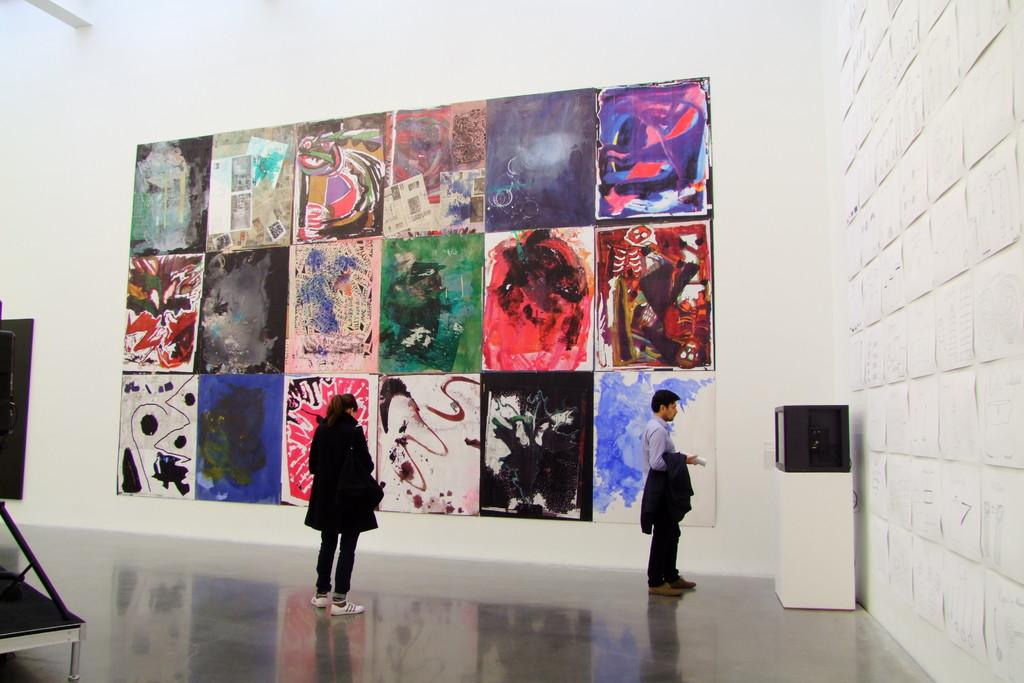How many people are present in the image? There are two people, a man and a woman, present in the image. What are the man and woman doing in the image? Both the man and woman are standing on the floor. What can be seen on the wall in the image? There are paintings on a wall in the image. What objects can be seen on the table in the image? There is an object and a device on a table in the image. What type of plantation is visible in the image? There is no plantation present in the image. What type of society is depicted in the image? The image does not depict a society; it features a man, a woman, paintings on a wall, and objects on a table. 